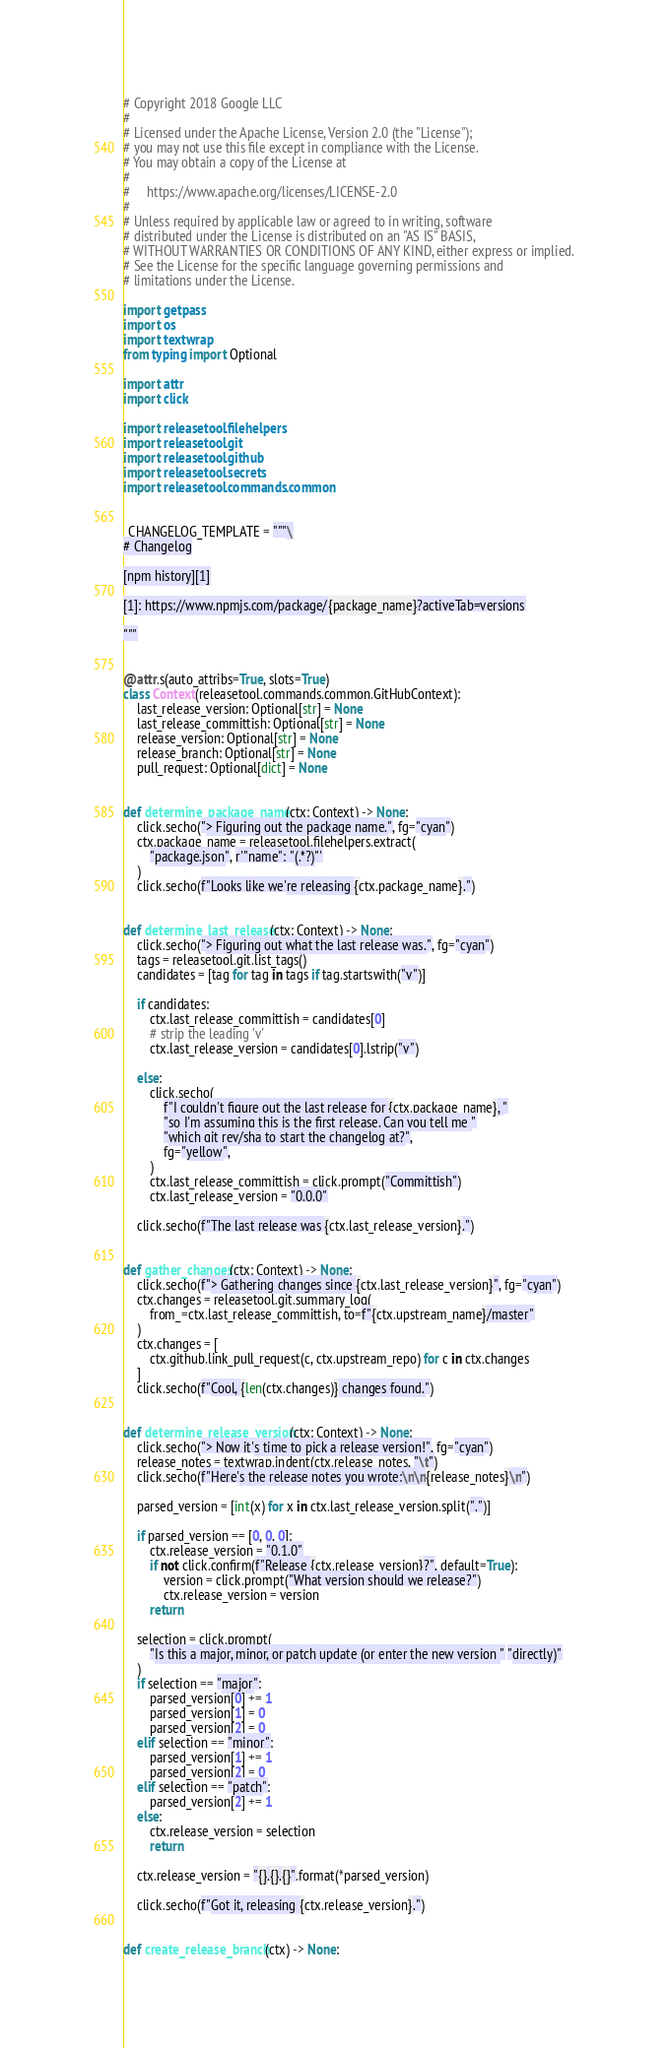<code> <loc_0><loc_0><loc_500><loc_500><_Python_># Copyright 2018 Google LLC
#
# Licensed under the Apache License, Version 2.0 (the "License");
# you may not use this file except in compliance with the License.
# You may obtain a copy of the License at
#
#     https://www.apache.org/licenses/LICENSE-2.0
#
# Unless required by applicable law or agreed to in writing, software
# distributed under the License is distributed on an "AS IS" BASIS,
# WITHOUT WARRANTIES OR CONDITIONS OF ANY KIND, either express or implied.
# See the License for the specific language governing permissions and
# limitations under the License.

import getpass
import os
import textwrap
from typing import Optional

import attr
import click

import releasetool.filehelpers
import releasetool.git
import releasetool.github
import releasetool.secrets
import releasetool.commands.common


_CHANGELOG_TEMPLATE = """\
# Changelog

[npm history][1]

[1]: https://www.npmjs.com/package/{package_name}?activeTab=versions

"""


@attr.s(auto_attribs=True, slots=True)
class Context(releasetool.commands.common.GitHubContext):
    last_release_version: Optional[str] = None
    last_release_committish: Optional[str] = None
    release_version: Optional[str] = None
    release_branch: Optional[str] = None
    pull_request: Optional[dict] = None


def determine_package_name(ctx: Context) -> None:
    click.secho("> Figuring out the package name.", fg="cyan")
    ctx.package_name = releasetool.filehelpers.extract(
        "package.json", r'"name": "(.*?)"'
    )
    click.secho(f"Looks like we're releasing {ctx.package_name}.")


def determine_last_release(ctx: Context) -> None:
    click.secho("> Figuring out what the last release was.", fg="cyan")
    tags = releasetool.git.list_tags()
    candidates = [tag for tag in tags if tag.startswith("v")]

    if candidates:
        ctx.last_release_committish = candidates[0]
        # strip the leading 'v'
        ctx.last_release_version = candidates[0].lstrip("v")

    else:
        click.secho(
            f"I couldn't figure out the last release for {ctx.package_name}, "
            "so I'm assuming this is the first release. Can you tell me "
            "which git rev/sha to start the changelog at?",
            fg="yellow",
        )
        ctx.last_release_committish = click.prompt("Committish")
        ctx.last_release_version = "0.0.0"

    click.secho(f"The last release was {ctx.last_release_version}.")


def gather_changes(ctx: Context) -> None:
    click.secho(f"> Gathering changes since {ctx.last_release_version}", fg="cyan")
    ctx.changes = releasetool.git.summary_log(
        from_=ctx.last_release_committish, to=f"{ctx.upstream_name}/master"
    )
    ctx.changes = [
        ctx.github.link_pull_request(c, ctx.upstream_repo) for c in ctx.changes
    ]
    click.secho(f"Cool, {len(ctx.changes)} changes found.")


def determine_release_version(ctx: Context) -> None:
    click.secho("> Now it's time to pick a release version!", fg="cyan")
    release_notes = textwrap.indent(ctx.release_notes, "\t")
    click.secho(f"Here's the release notes you wrote:\n\n{release_notes}\n")

    parsed_version = [int(x) for x in ctx.last_release_version.split(".")]

    if parsed_version == [0, 0, 0]:
        ctx.release_version = "0.1.0"
        if not click.confirm(f"Release {ctx.release_version}?", default=True):
            version = click.prompt("What version should we release?")
            ctx.release_version = version
        return

    selection = click.prompt(
        "Is this a major, minor, or patch update (or enter the new version " "directly)"
    )
    if selection == "major":
        parsed_version[0] += 1
        parsed_version[1] = 0
        parsed_version[2] = 0
    elif selection == "minor":
        parsed_version[1] += 1
        parsed_version[2] = 0
    elif selection == "patch":
        parsed_version[2] += 1
    else:
        ctx.release_version = selection
        return

    ctx.release_version = "{}.{}.{}".format(*parsed_version)

    click.secho(f"Got it, releasing {ctx.release_version}.")


def create_release_branch(ctx) -> None:</code> 